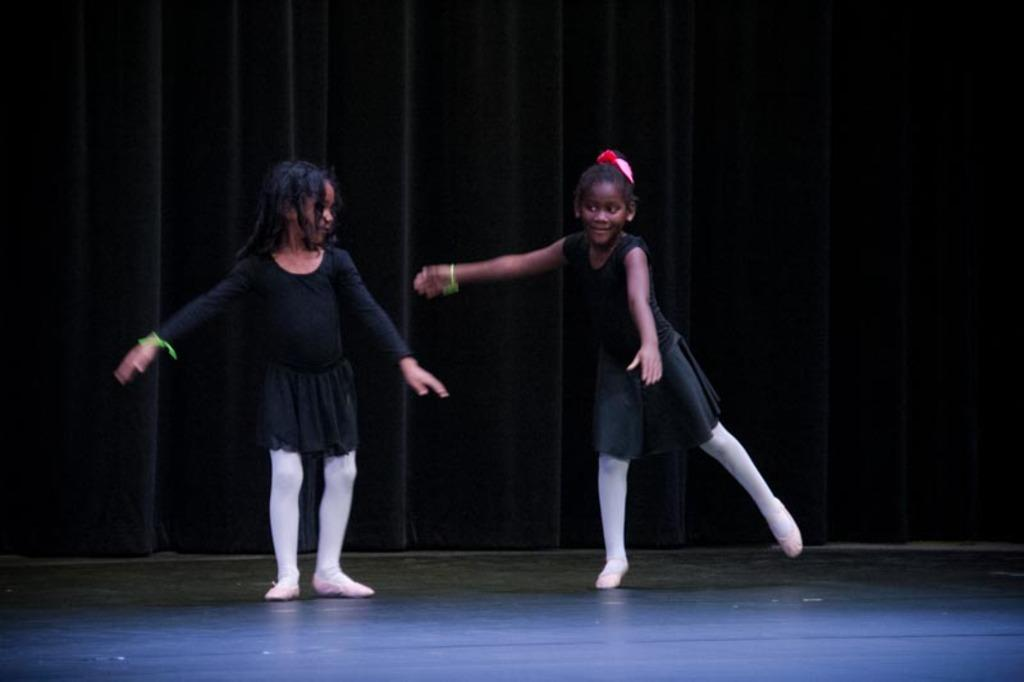How many girls are in the image? There are two girls in the image. What are the girls wearing? The girls are wearing clothes, hand bands, and shoes. What activity are the girls engaged in? The girls are dancing. What is the surface they are dancing on? There is a floor visible in the image. What can be seen in the background while the girls are dancing? There are curtains in the image. What type of zebra is visible in the image? There is no zebra present in the image. What type of apparel is the zebra wearing in the image? There is no zebra present in the image, so it is not possible to determine what type of apparel it might be wearing. 